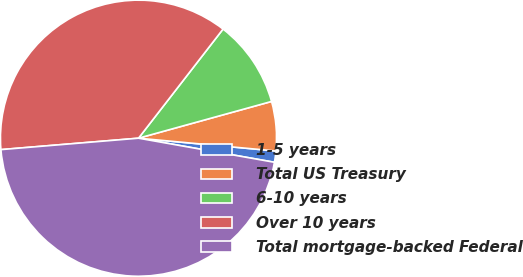Convert chart. <chart><loc_0><loc_0><loc_500><loc_500><pie_chart><fcel>1-5 years<fcel>Total US Treasury<fcel>6-10 years<fcel>Over 10 years<fcel>Total mortgage-backed Federal<nl><fcel>1.31%<fcel>5.77%<fcel>10.22%<fcel>36.81%<fcel>45.89%<nl></chart> 